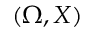<formula> <loc_0><loc_0><loc_500><loc_500>( \Omega , X )</formula> 